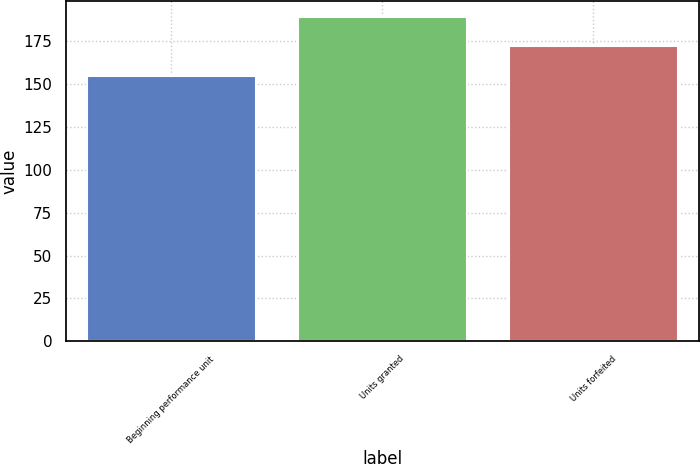<chart> <loc_0><loc_0><loc_500><loc_500><bar_chart><fcel>Beginning performance unit<fcel>Units granted<fcel>Units forfeited<nl><fcel>154.53<fcel>189.23<fcel>172.02<nl></chart> 